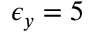<formula> <loc_0><loc_0><loc_500><loc_500>\epsilon _ { y } = 5 \</formula> 